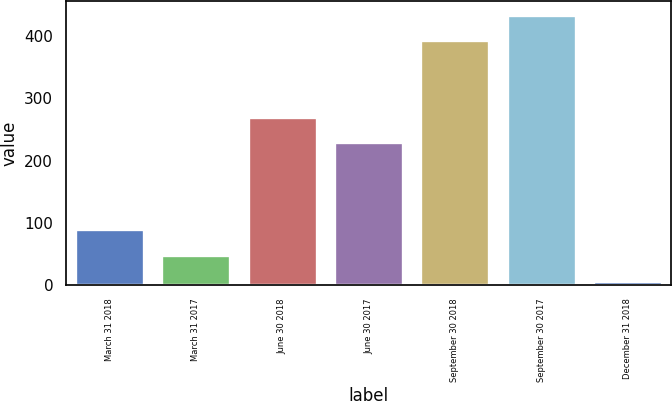<chart> <loc_0><loc_0><loc_500><loc_500><bar_chart><fcel>March 31 2018<fcel>March 31 2017<fcel>June 30 2018<fcel>June 30 2017<fcel>September 30 2018<fcel>September 30 2017<fcel>December 31 2018<nl><fcel>90<fcel>47.5<fcel>270.5<fcel>230<fcel>394<fcel>434.5<fcel>7<nl></chart> 